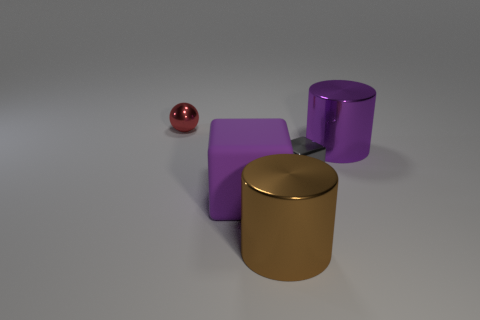Add 1 big rubber balls. How many objects exist? 6 Subtract all blocks. How many objects are left? 3 Add 4 large yellow matte balls. How many large yellow matte balls exist? 4 Subtract 0 cyan blocks. How many objects are left? 5 Subtract all large purple blocks. Subtract all large purple cylinders. How many objects are left? 3 Add 2 red metal things. How many red metal things are left? 3 